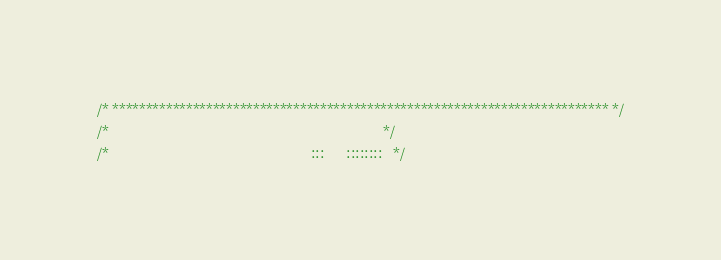<code> <loc_0><loc_0><loc_500><loc_500><_C_>/* ************************************************************************** */
/*                                                                            */
/*                                                        :::      ::::::::   */</code> 